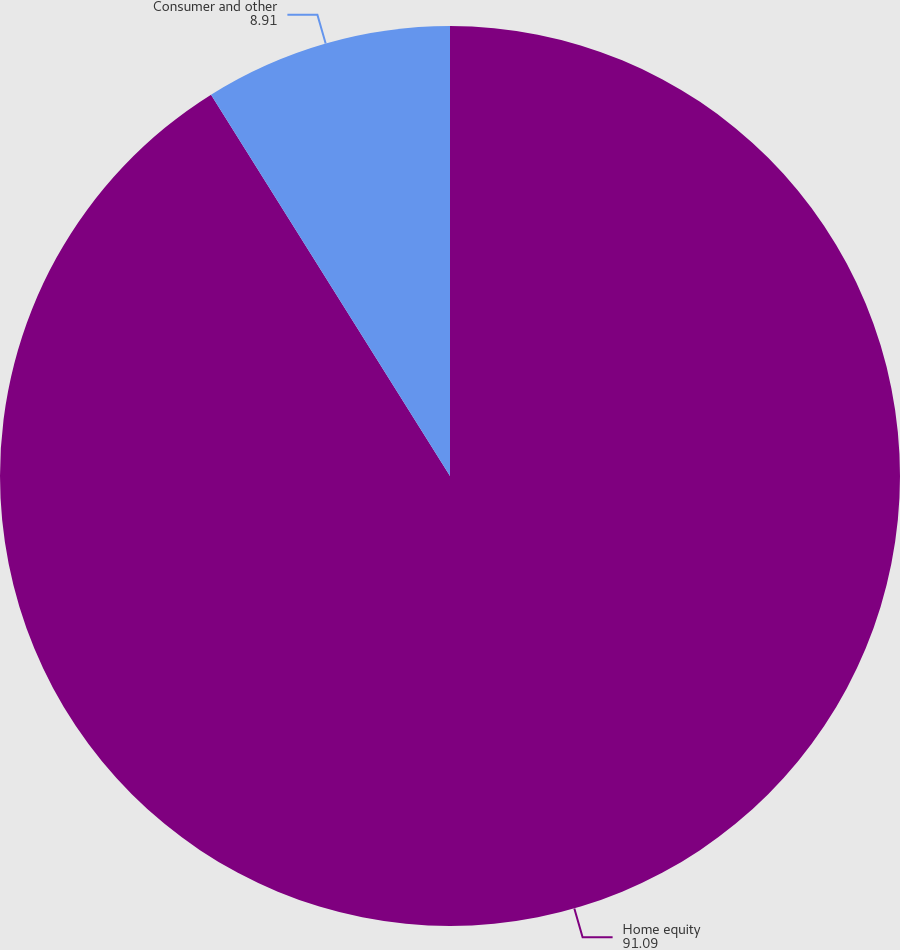Convert chart to OTSL. <chart><loc_0><loc_0><loc_500><loc_500><pie_chart><fcel>Home equity<fcel>Consumer and other<nl><fcel>91.09%<fcel>8.91%<nl></chart> 